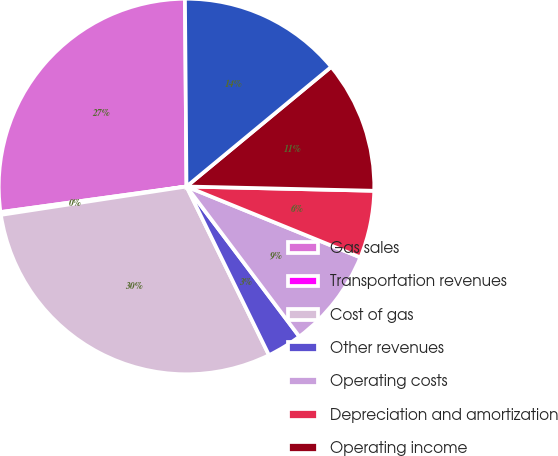<chart> <loc_0><loc_0><loc_500><loc_500><pie_chart><fcel>Gas sales<fcel>Transportation revenues<fcel>Cost of gas<fcel>Other revenues<fcel>Operating costs<fcel>Depreciation and amortization<fcel>Operating income<fcel>Capital expenditures<nl><fcel>27.05%<fcel>0.24%<fcel>29.83%<fcel>3.02%<fcel>8.58%<fcel>5.8%<fcel>11.36%<fcel>14.14%<nl></chart> 